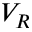Convert formula to latex. <formula><loc_0><loc_0><loc_500><loc_500>V _ { R }</formula> 